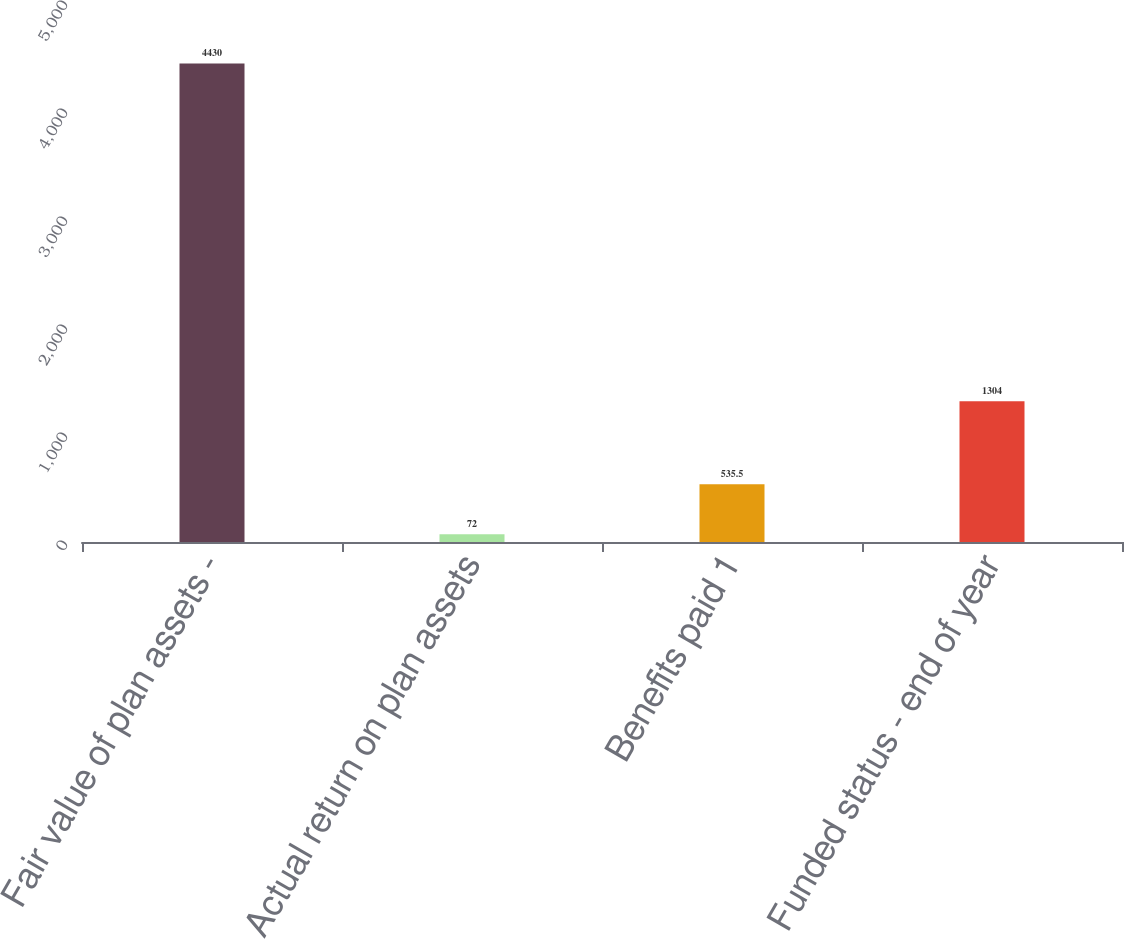Convert chart. <chart><loc_0><loc_0><loc_500><loc_500><bar_chart><fcel>Fair value of plan assets -<fcel>Actual return on plan assets<fcel>Benefits paid 1<fcel>Funded status - end of year<nl><fcel>4430<fcel>72<fcel>535.5<fcel>1304<nl></chart> 